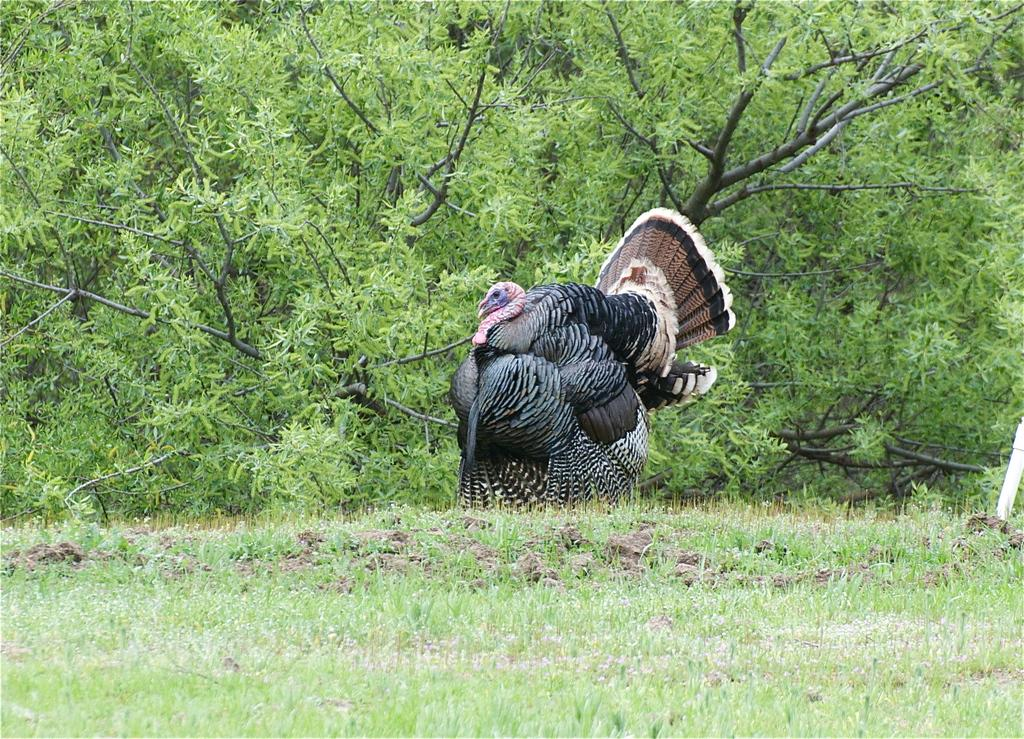What type of plants are visible in the image? The image contains plants. Where is the flag located in the image? The flag is on the left side of the image. Can any structures be identified in the image? Yes, there is at least one building present in the image. What is visible in the background of the image? Trees and the sky are visible in the background of the image. How many flags are visible, and where are they positioned? There is one flag, and it is positioned on the left side of the image. What type of queen can be seen visiting the building in the image? There is no queen present in the image, and therefore no such visit can be observed. Can you tell me how many goats are grazing in the background of the image? There are no goats present in the image; it features plants, a flag, a building, trees, and the sky. 